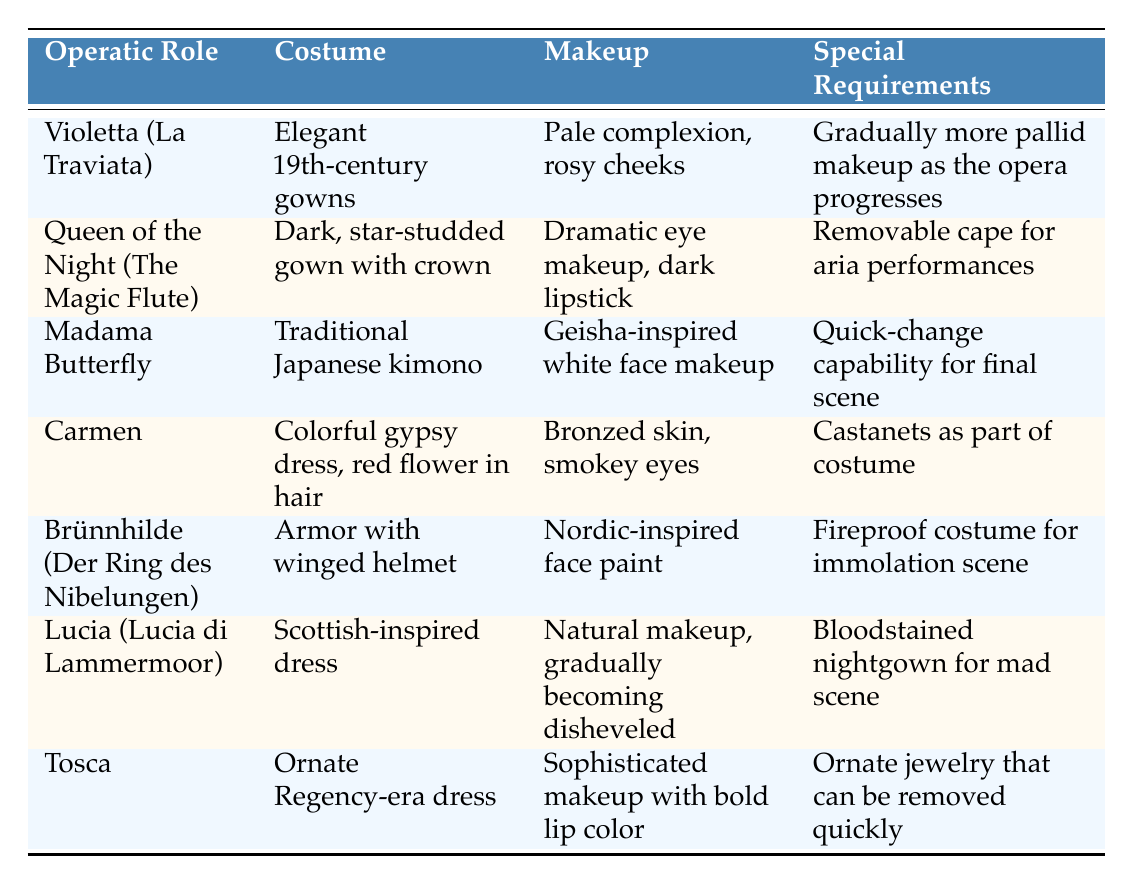What costume does Violetta wear in La Traviata? The table clearly states that Violetta wears "Elegant 19th-century gowns" as her costume.
Answer: Elegant 19th-century gowns Does the Queen of the Night require any special makeup for her role? According to the table, the Queen of the Night requires "Dramatic eye makeup, dark lipstick," indicating that special makeup is necessary.
Answer: Yes What are the special requirements for Madama Butterfly? The table specifies that Madama Butterfly has "Quick-change capability for final scene" as her special requirement.
Answer: Quick-change capability for final scene Which operatic role has a costume that includes armor? The table shows that Brünnhilde from Der Ring des Nibelungen has "Armor with winged helmet" as part of her costume.
Answer: Brünnhilde (Der Ring des Nibelungen) Which character's makeup is described as becoming disheveled? Lucia from Lucia di Lammermoor has "Natural makeup, gradually becoming disheveled" noted in the makeup column.
Answer: Lucia (Lucia di Lammermoor) Are there any characters that wear a gown made from traditional materials? The table indicates that Madama Butterfly wears a "Traditional Japanese kimono," confirming that she represents traditional materials in her costume.
Answer: Yes Which character requires a fireproof costume? The table indicates that Brünnhilde requires "Fireproof costume for immolation scene," pointing to this specific need.
Answer: Brünnhilde (Der Ring des Nibelungen) How many characters have specific makeup that is dramatic or bold? Reviewing the table, both the Queen of the Night ("Dramatic eye makeup, dark lipstick") and Tosca ("Sophisticated makeup with bold lip color") have been noted for dramatic or bold makeup, totaling two characters.
Answer: 2 What is the difference in the special requirements between Carmen and Tosca? Carmen's special requirement includes "Castanets as part of costume," while Tosca requires "Ornate jewelry that can be removed quickly." This shows that they have different special requirements related to their respective costumes.
Answer: Different special requirements related to costumes Do all the characters in the table require some form of makeup? The table notes specific makeup requirements for each character, confirming that indeed all characters have makeup requirements.
Answer: Yes 